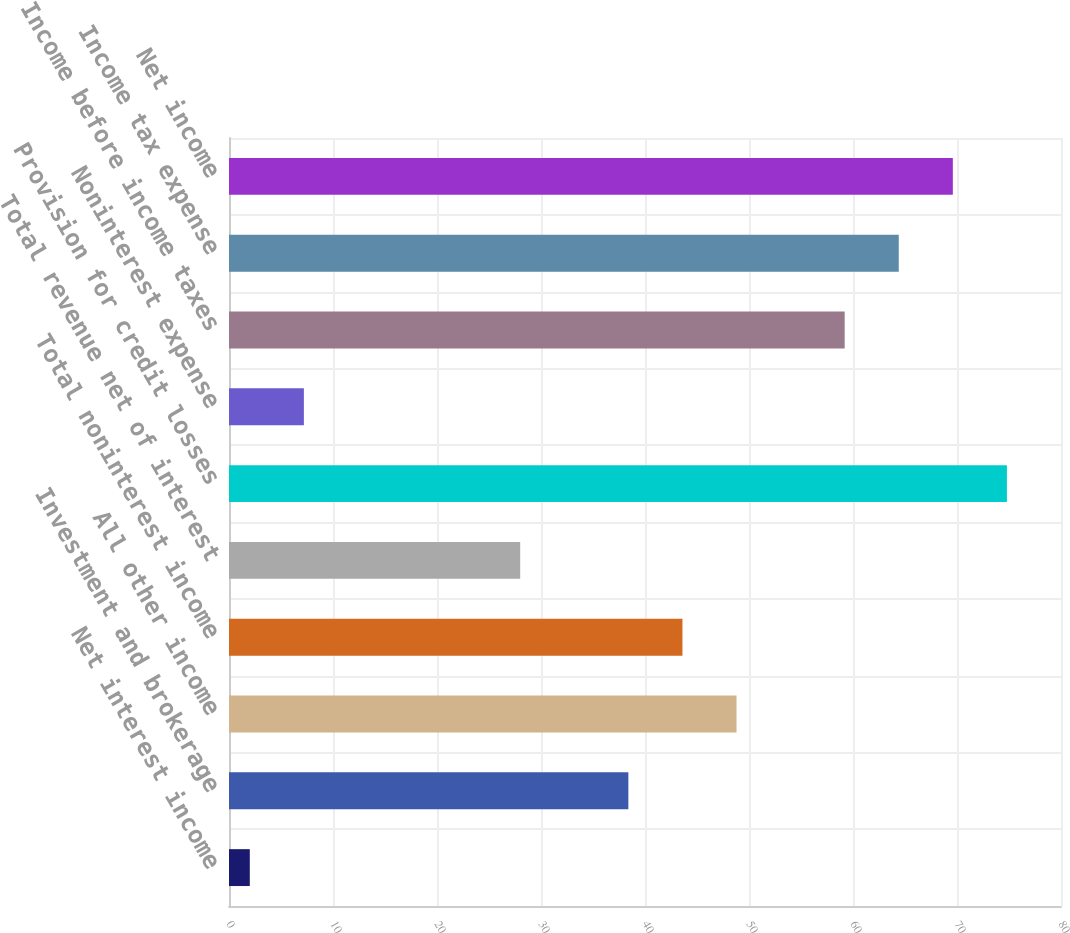Convert chart to OTSL. <chart><loc_0><loc_0><loc_500><loc_500><bar_chart><fcel>Net interest income<fcel>Investment and brokerage<fcel>All other income<fcel>Total noninterest income<fcel>Total revenue net of interest<fcel>Provision for credit losses<fcel>Noninterest expense<fcel>Income before income taxes<fcel>Income tax expense<fcel>Net income<nl><fcel>2<fcel>38.4<fcel>48.8<fcel>43.6<fcel>28<fcel>74.8<fcel>7.2<fcel>59.2<fcel>64.4<fcel>69.6<nl></chart> 